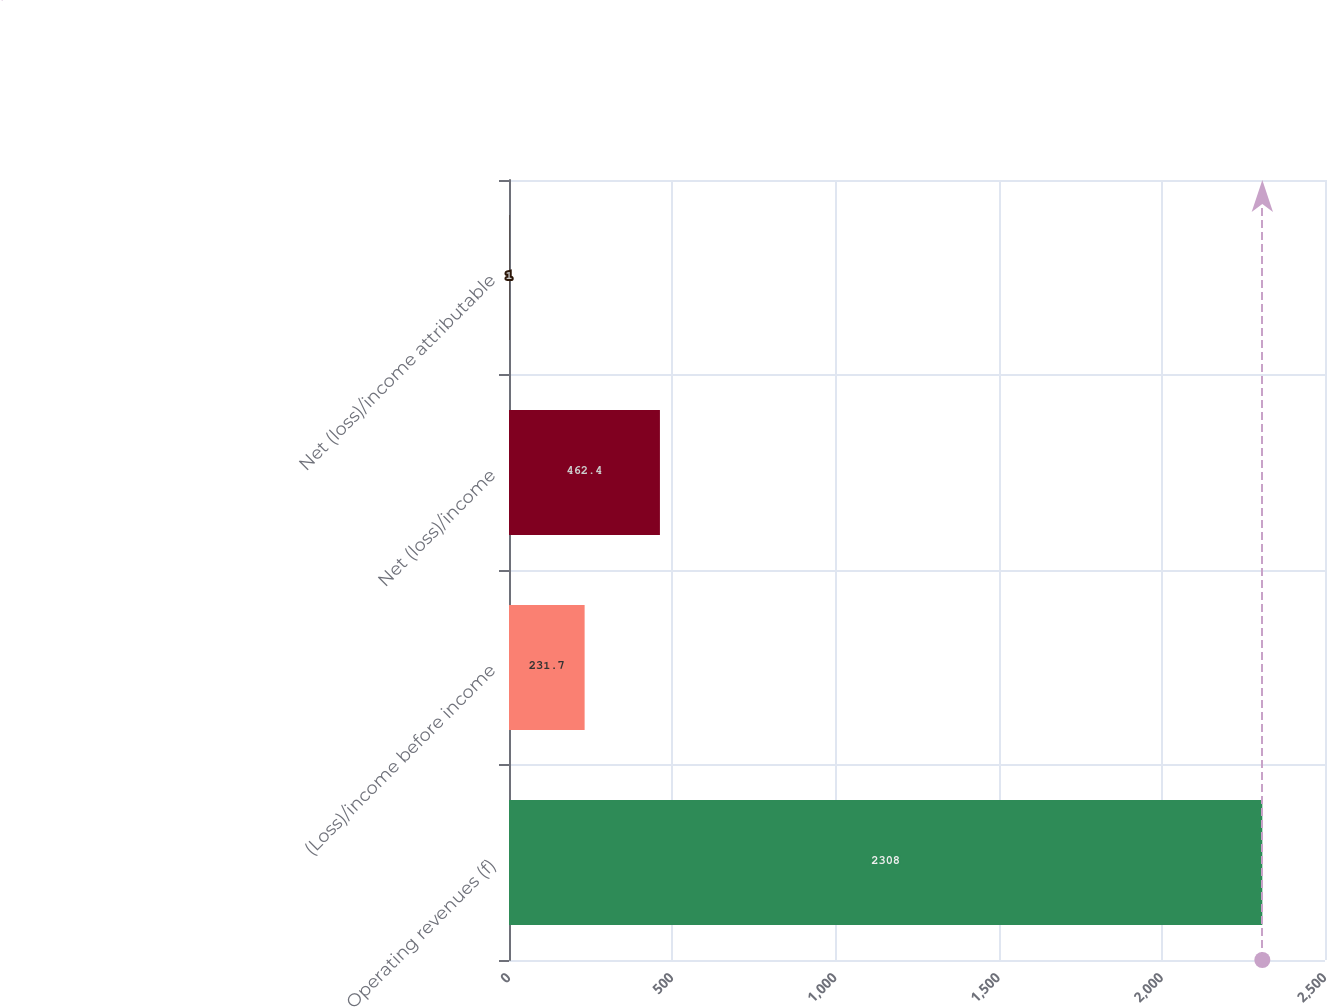Convert chart to OTSL. <chart><loc_0><loc_0><loc_500><loc_500><bar_chart><fcel>Operating revenues (f)<fcel>(Loss)/income before income<fcel>Net (loss)/income<fcel>Net (loss)/income attributable<nl><fcel>2308<fcel>231.7<fcel>462.4<fcel>1<nl></chart> 